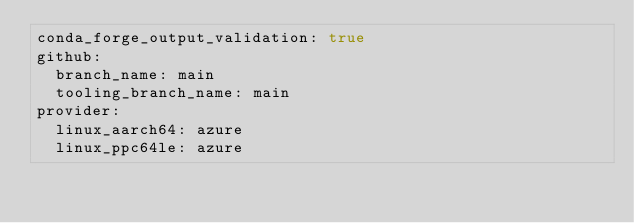Convert code to text. <code><loc_0><loc_0><loc_500><loc_500><_YAML_>conda_forge_output_validation: true
github:
  branch_name: main
  tooling_branch_name: main
provider:
  linux_aarch64: azure
  linux_ppc64le: azure
</code> 